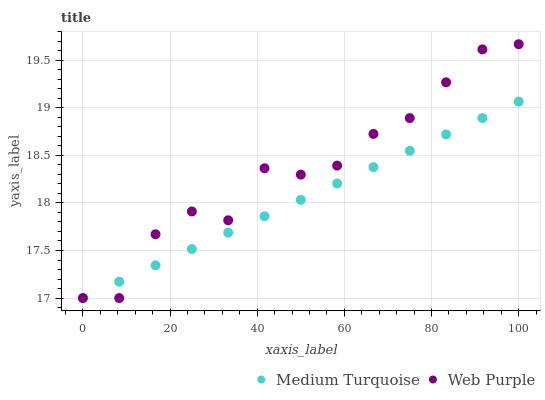Does Medium Turquoise have the minimum area under the curve?
Answer yes or no. Yes. Does Web Purple have the maximum area under the curve?
Answer yes or no. Yes. Does Medium Turquoise have the maximum area under the curve?
Answer yes or no. No. Is Medium Turquoise the smoothest?
Answer yes or no. Yes. Is Web Purple the roughest?
Answer yes or no. Yes. Is Medium Turquoise the roughest?
Answer yes or no. No. Does Web Purple have the lowest value?
Answer yes or no. Yes. Does Web Purple have the highest value?
Answer yes or no. Yes. Does Medium Turquoise have the highest value?
Answer yes or no. No. Does Web Purple intersect Medium Turquoise?
Answer yes or no. Yes. Is Web Purple less than Medium Turquoise?
Answer yes or no. No. Is Web Purple greater than Medium Turquoise?
Answer yes or no. No. 